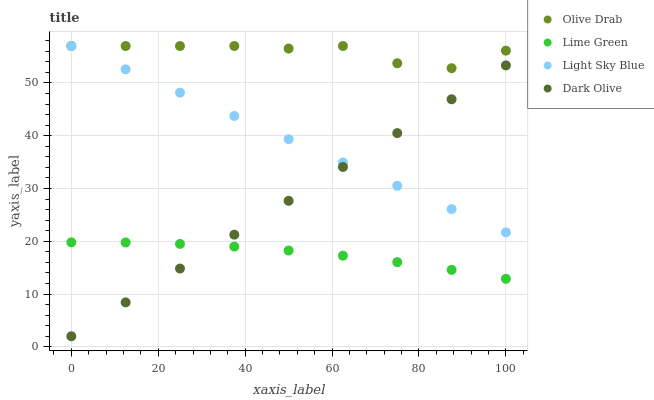Does Lime Green have the minimum area under the curve?
Answer yes or no. Yes. Does Olive Drab have the maximum area under the curve?
Answer yes or no. Yes. Does Light Sky Blue have the minimum area under the curve?
Answer yes or no. No. Does Light Sky Blue have the maximum area under the curve?
Answer yes or no. No. Is Light Sky Blue the smoothest?
Answer yes or no. Yes. Is Olive Drab the roughest?
Answer yes or no. Yes. Is Lime Green the smoothest?
Answer yes or no. No. Is Lime Green the roughest?
Answer yes or no. No. Does Dark Olive have the lowest value?
Answer yes or no. Yes. Does Light Sky Blue have the lowest value?
Answer yes or no. No. Does Olive Drab have the highest value?
Answer yes or no. Yes. Does Lime Green have the highest value?
Answer yes or no. No. Is Dark Olive less than Olive Drab?
Answer yes or no. Yes. Is Light Sky Blue greater than Lime Green?
Answer yes or no. Yes. Does Dark Olive intersect Light Sky Blue?
Answer yes or no. Yes. Is Dark Olive less than Light Sky Blue?
Answer yes or no. No. Is Dark Olive greater than Light Sky Blue?
Answer yes or no. No. Does Dark Olive intersect Olive Drab?
Answer yes or no. No. 